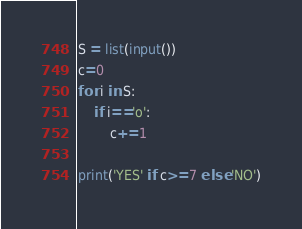<code> <loc_0><loc_0><loc_500><loc_500><_Python_>S = list(input())
c=0
for i in S:
    if i=='o':
        c+=1
        
print('YES' if c>=7 else 'NO')</code> 